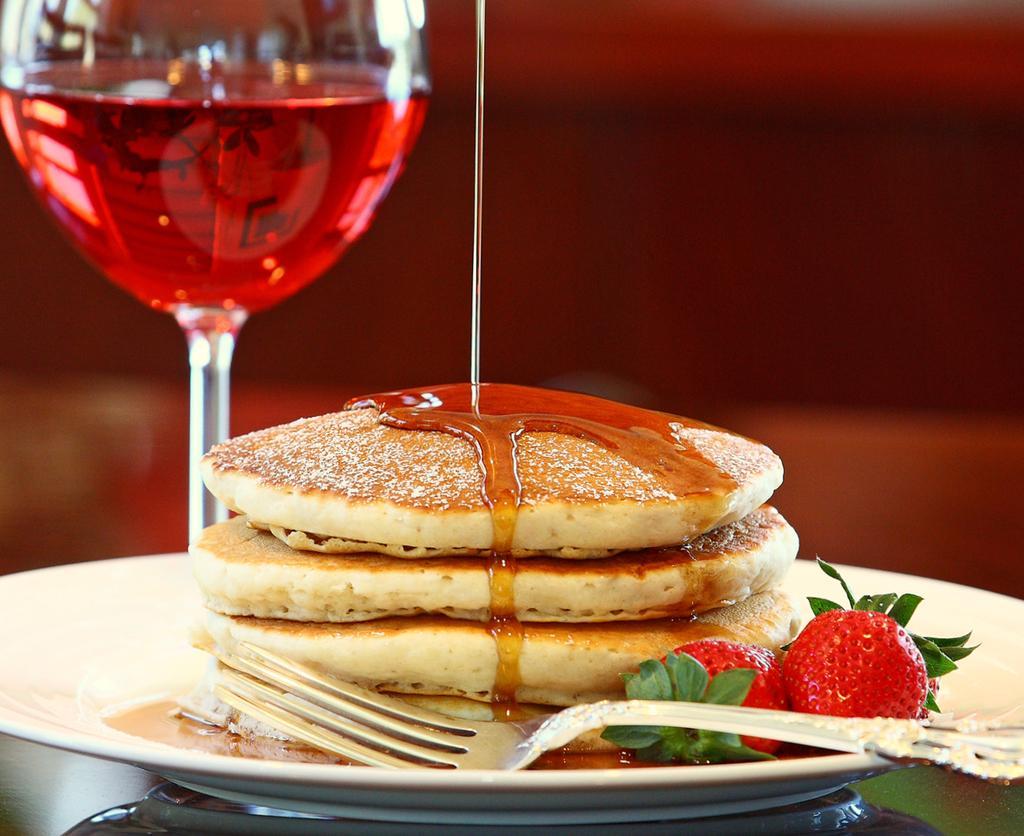How would you summarize this image in a sentence or two? In this image there is a table, on that table there is a plate in that plate there are some food items and a spoon there is a glass in that glass there is a liquid. 